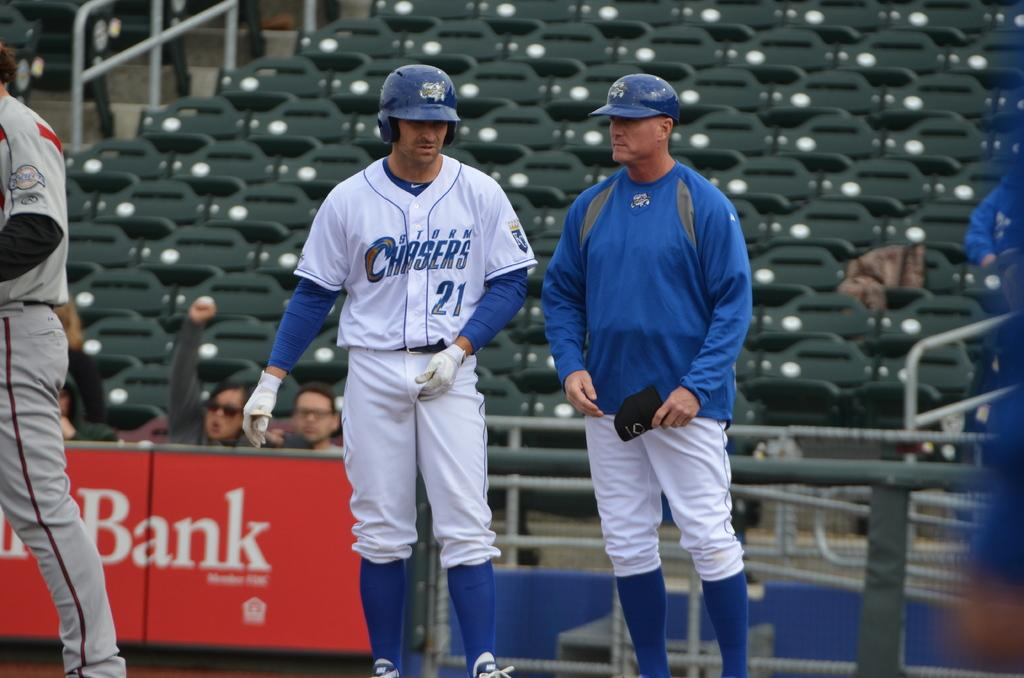Provide a one-sentence caption for the provided image. Two baseball players  for the Storm Chasers stand together on the field. 